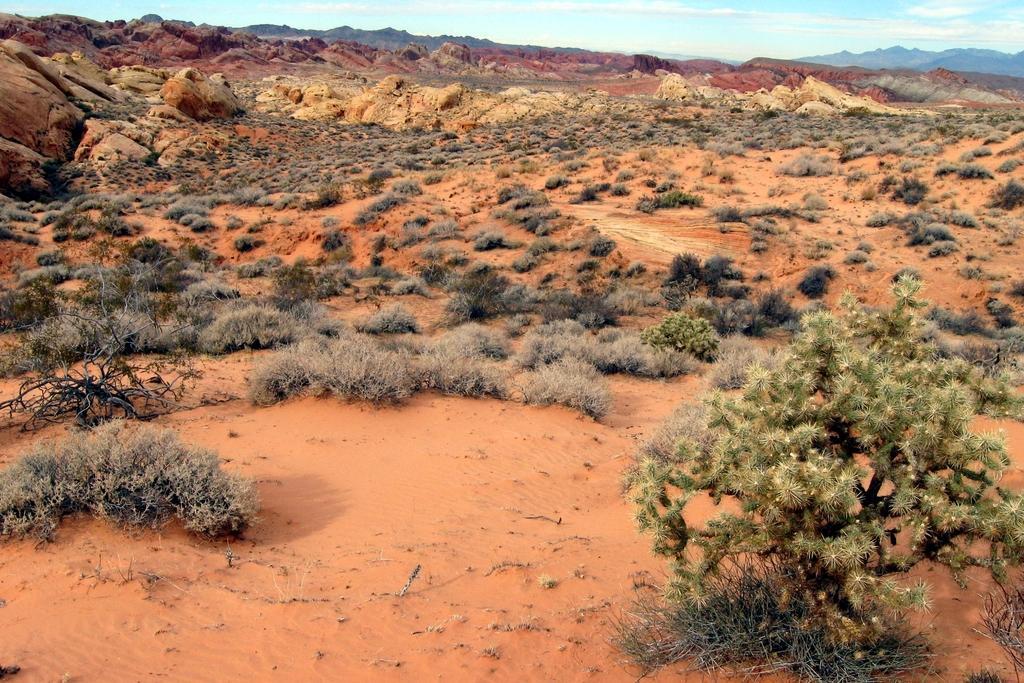Can you describe this image briefly? In this image there is the sky towards the top of the image, there are clouds in the sky, there are mountains, there is ground towards the bottom of the image, there are rocks on the ground, there are plants on the ground. 